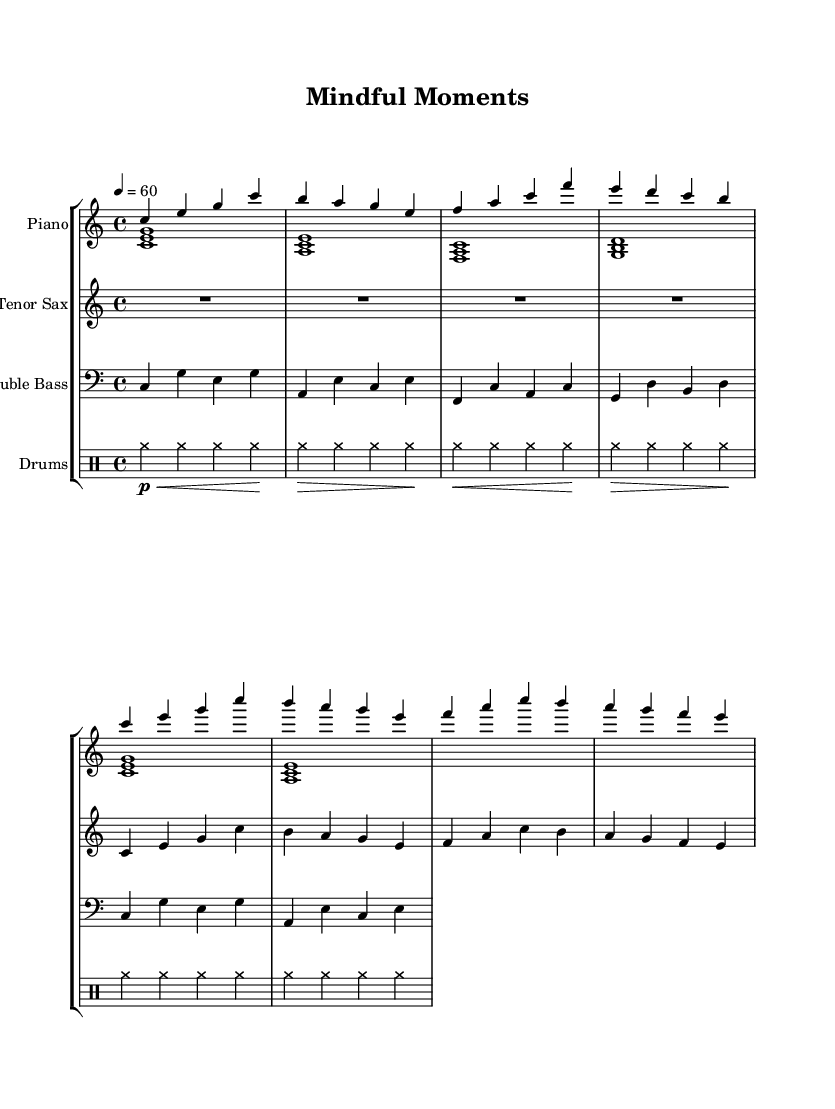What is the key signature of this music? The key signature is C major, which can be identified by the absence of any sharps or flats at the beginning of the staff.
Answer: C major What is the time signature of this piece? The time signature is indicated by the fraction found at the beginning of the score; here, it is 4/4, meaning there are four beats in each measure.
Answer: 4/4 What is the tempo marking for this piece? The tempo marking is found at the beginning, where it specifies a speed of 60 beats per minute, indicated by the '4 = 60' notation.
Answer: 60 How many measures are presented in the intro section? By counting the measures indicated in the score, the intro comprises four measures before transitioning to the A section.
Answer: 4 What type of jazz is exemplified by the title "Mindful Moments"? The title suggests a focus on mindfulness, which aligns with a subgenre of jazz known as "cool jazz," characterized by its relaxed tempo and soft tones.
Answer: Cool jazz Which instrument plays the melody primarily in this score? On examining the score, the tenor saxophone is primarily assigned the melody; it carries the main thematic material, particularly in the A section.
Answer: Tenor saxophone What is the role of the drums in this piece? The drums are indicated as maintaining a steady rhythm throughout the piece, specifically through the use of cymbals, which help create a smooth, relaxed atmosphere typical in cool jazz.
Answer: Rhythm section 